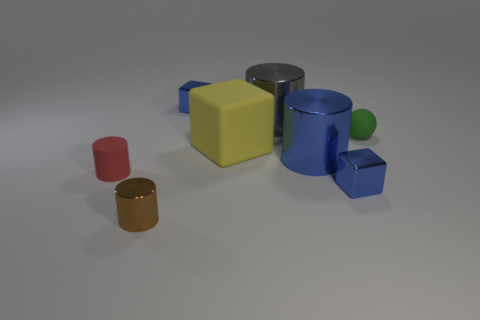Add 2 large blue objects. How many objects exist? 10 Subtract all blocks. How many objects are left? 5 Add 4 tiny metal balls. How many tiny metal balls exist? 4 Subtract 0 blue spheres. How many objects are left? 8 Subtract all small metal things. Subtract all green objects. How many objects are left? 4 Add 2 tiny blocks. How many tiny blocks are left? 4 